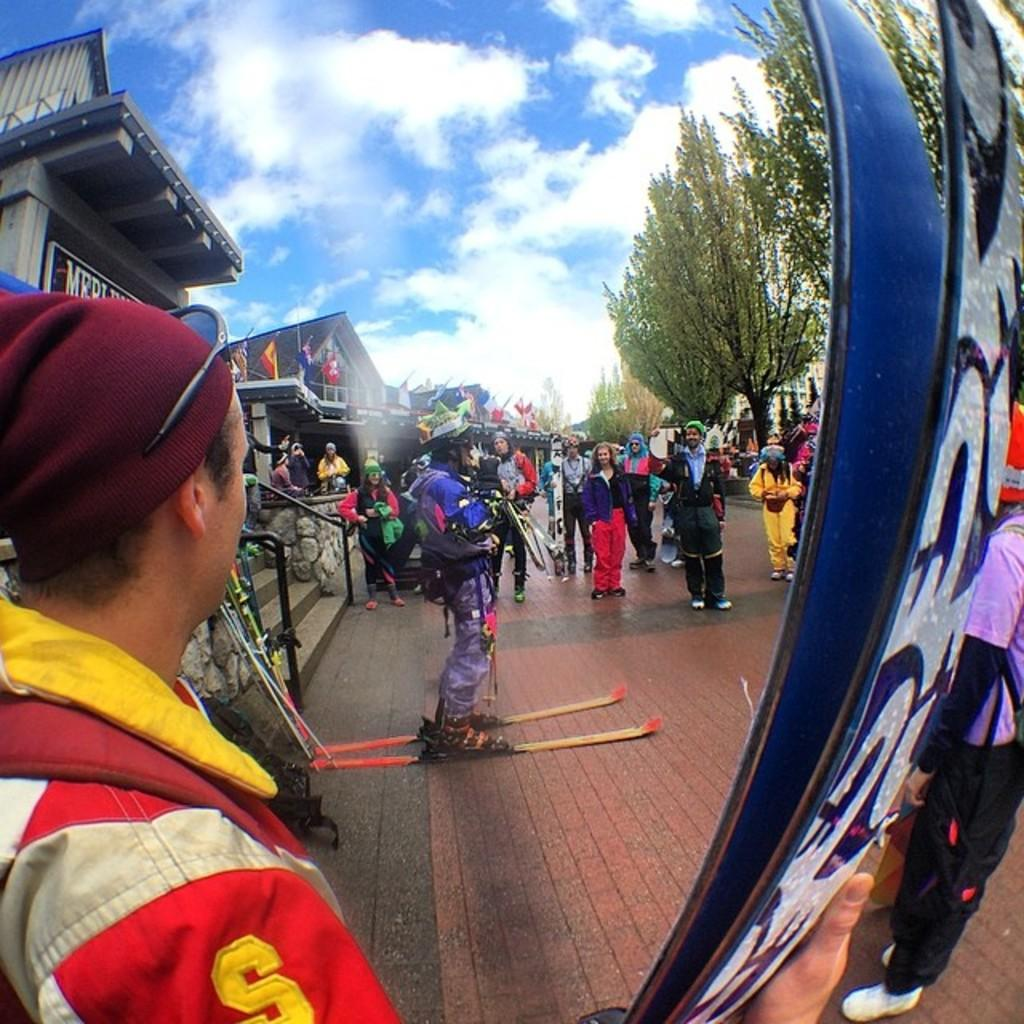Provide a one-sentence caption for the provided image. A person wearing a red outfit with the letter s with other skiers. 